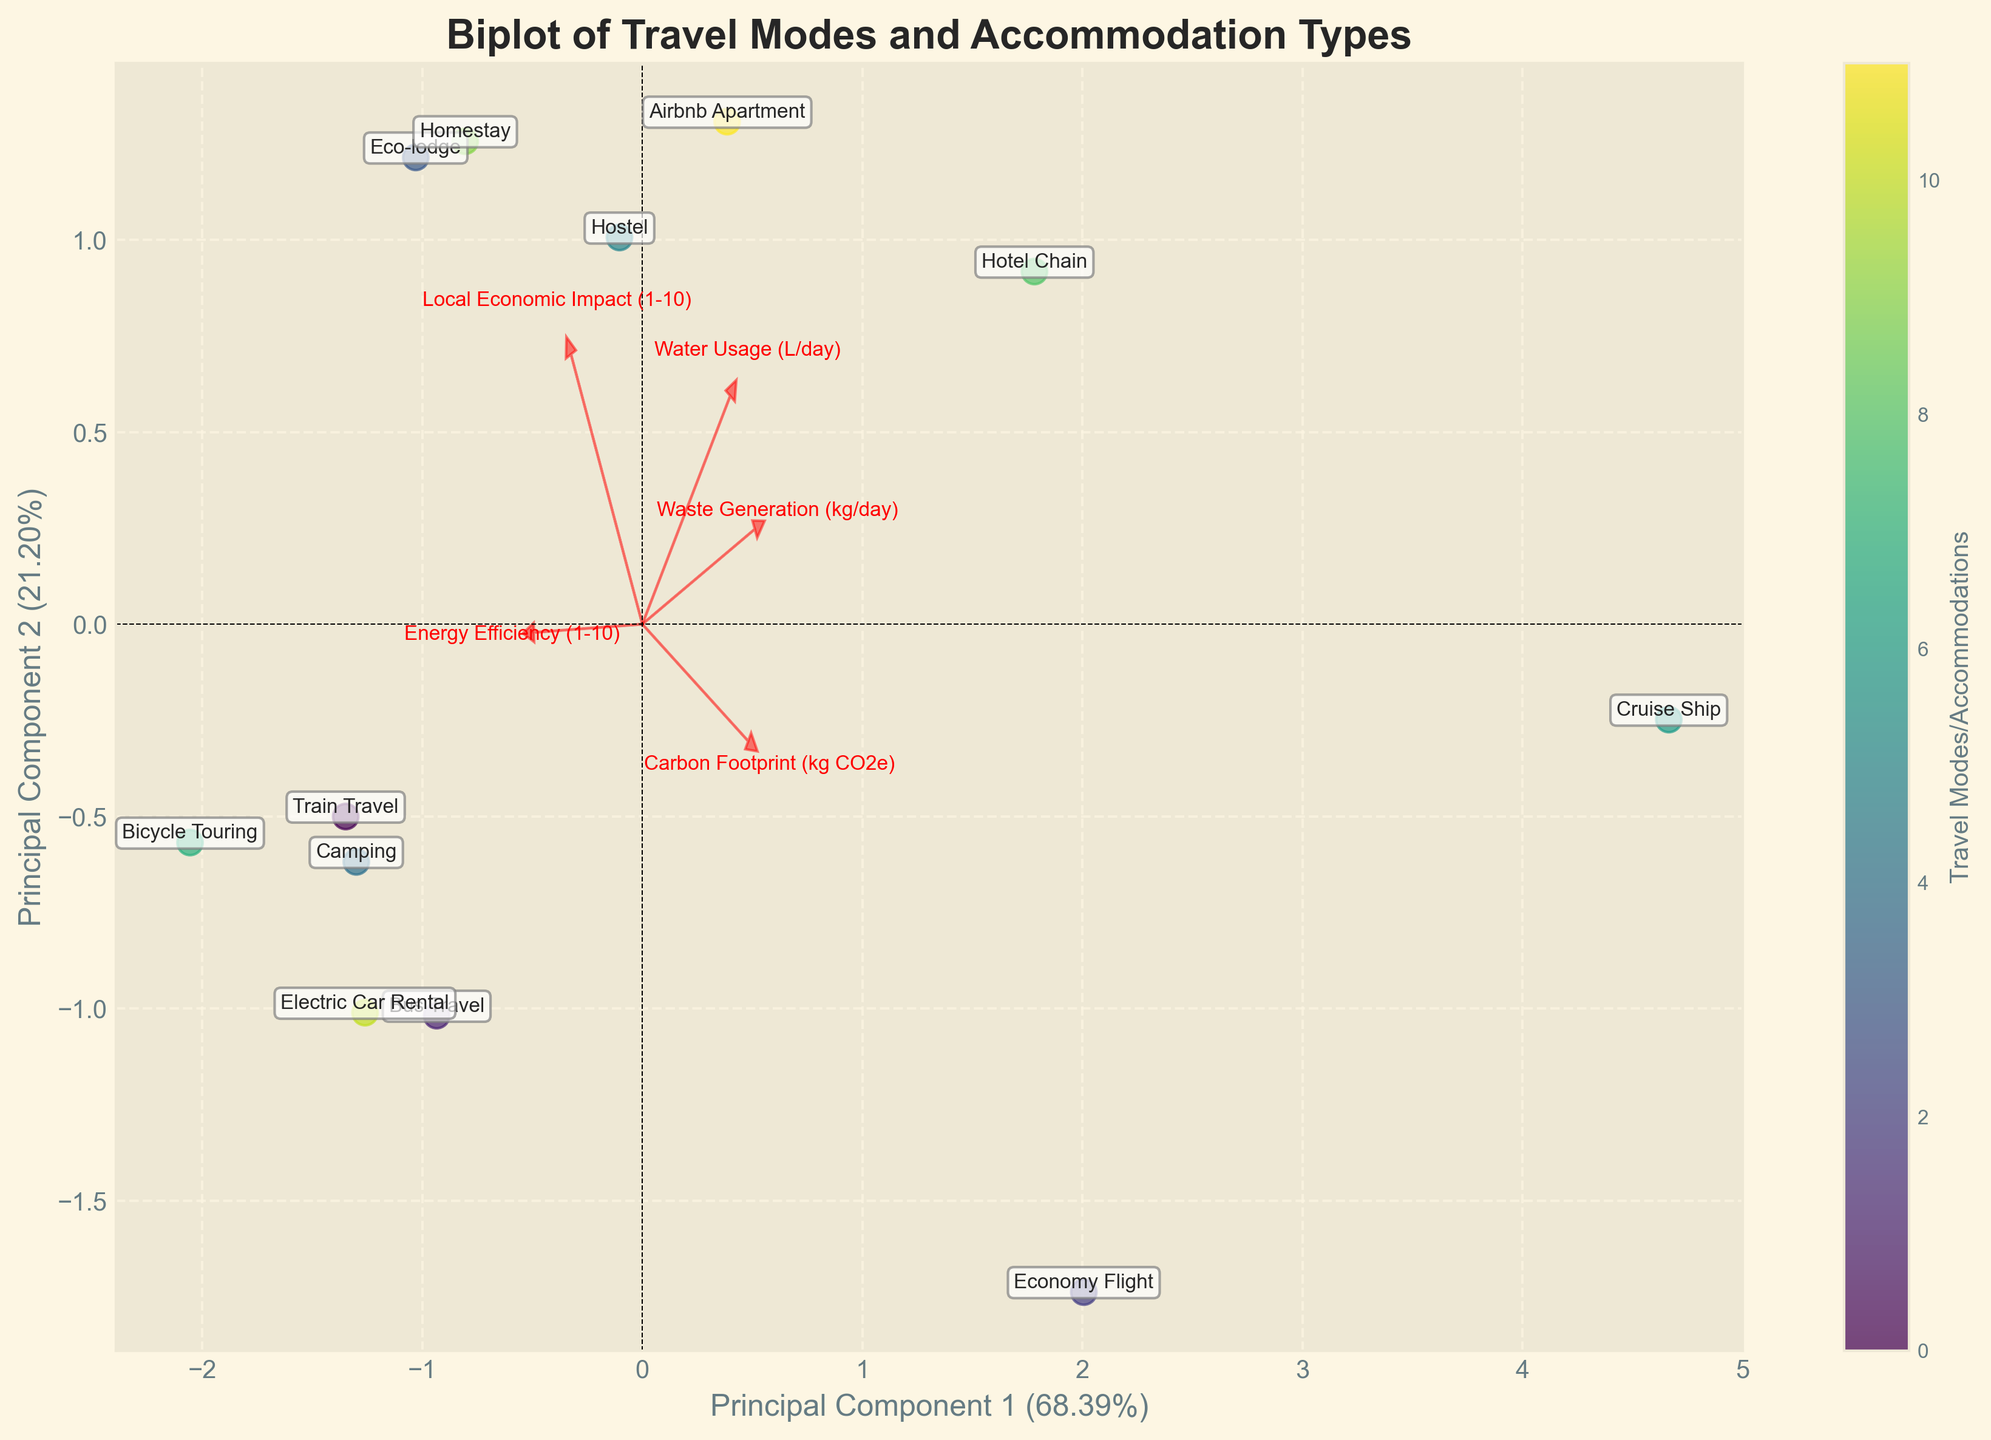what is the title of the figure? The title is typically located at the top center of the figure. In this case, it reads "Biplot of Travel Modes and Accommodation Types"
Answer: Biplot of Travel Modes and Accommodation Types How are the data points represented in the plot? You can see scattered points with labels for each travel mode and accommodation type. The scatter points are color-coded and have annotations.
Answer: Color-coded scatter points with labels Which travel mode or accommodation has the highest carbon footprint? By looking at the position and the annotation close to one end of a component pointing towards high carbon footprint, it is evident that "Cruise Ship" is furthest in that direction.
Answer: Cruise Ship How do the Water Usage and Waste Generation features relate to Principal Component 1 and 2? The arrows for Water Usage and Waste Generation are used to determine their correlation. They point outwards, showing how they spread in the plot relative to the principal components.
Answer: Water Usage and Waste Generation have moderately strong relationships with the principal components Which point is closest to the origin? The data point closest to the origin (coordinate [0,0]) would be the one closest to it visually when plotted. This can be identified by visually checking the scatter points.
Answer: Bicycle Touring What is the range of the explained variance ratio for the principal components? The range of the explained variance ratio can be identified from the x-axis and y-axis labels. Principal Component 1 and Component 2 explain certain percentages of the variance.
Answer: Approximately 40% to 60% Which mode or accommodation has the best energy efficiency and how is it represented? By looking at the arrow direction and space correlation indicating energy efficiency, it appears that "Camping" is near the highest value for energy efficiency.
Answer: Camping How does the Eco-lodge compare with the Economy Flight in terms of local economic impact? By comparing the labeled positions of the Eco-lodge and Economy Flight, the direction and spread of local economic impact arrows help determine the comparison.
Answer: Eco-lodge has higher impact Which vectors indicate the strongest features contributing to the principal components? The strength of the contributing features is visualized by the length and direction of the vectors plotted in the biplot. Longer vectors indicate stronger contributions.
Answer: Carbon Footprint and Energy Efficiency Which accommodations have a high water usage but low carbon footprint? Observing the direction and spread of water usage with a low carbon footprint using the biplot showcases Eco-lodge and Camping.
Answer: Eco-lodge and Camping 